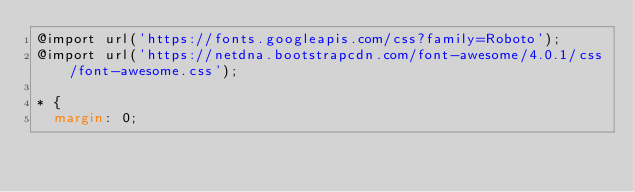Convert code to text. <code><loc_0><loc_0><loc_500><loc_500><_CSS_>@import url('https://fonts.googleapis.com/css?family=Roboto');
@import url('https://netdna.bootstrapcdn.com/font-awesome/4.0.1/css/font-awesome.css');

* {
  margin: 0;</code> 